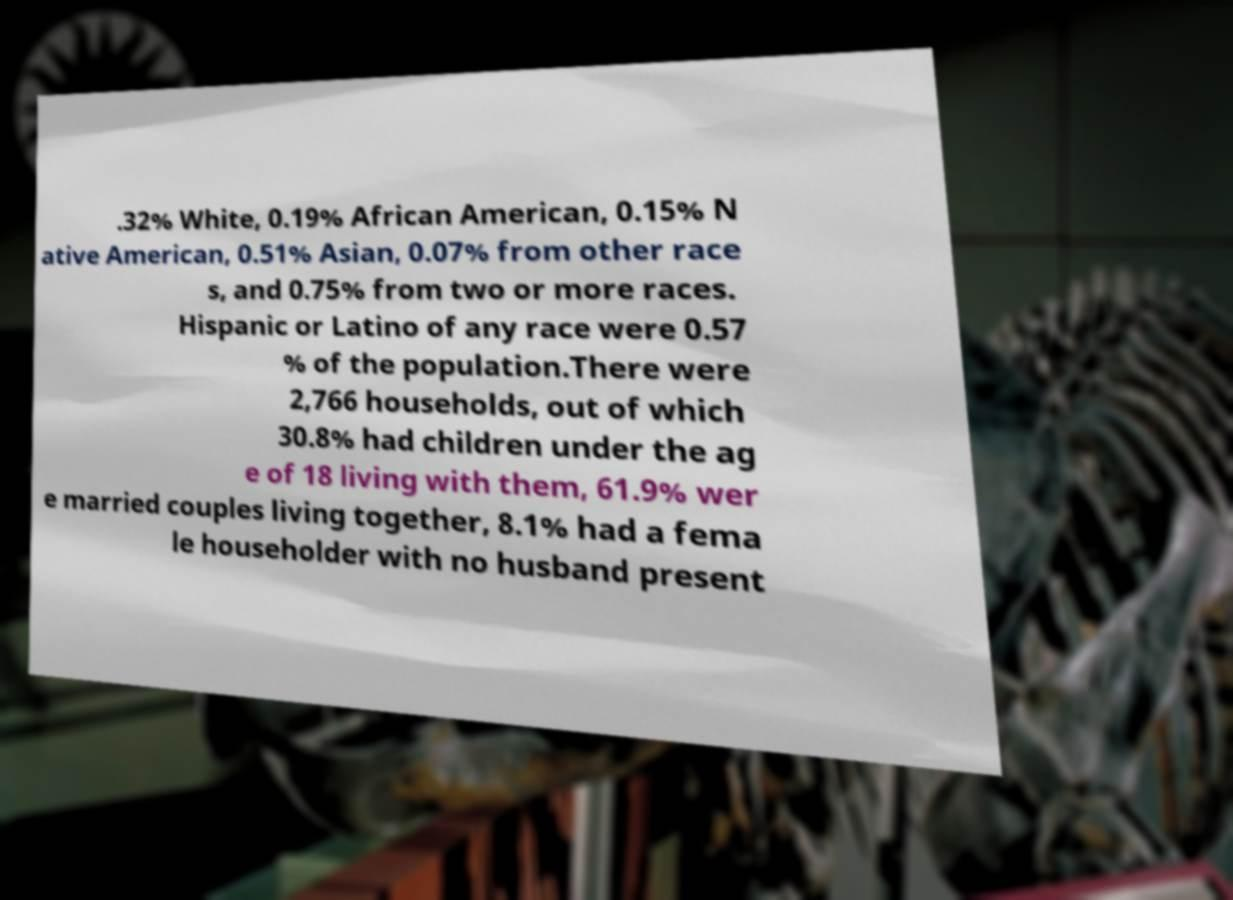Can you accurately transcribe the text from the provided image for me? .32% White, 0.19% African American, 0.15% N ative American, 0.51% Asian, 0.07% from other race s, and 0.75% from two or more races. Hispanic or Latino of any race were 0.57 % of the population.There were 2,766 households, out of which 30.8% had children under the ag e of 18 living with them, 61.9% wer e married couples living together, 8.1% had a fema le householder with no husband present 